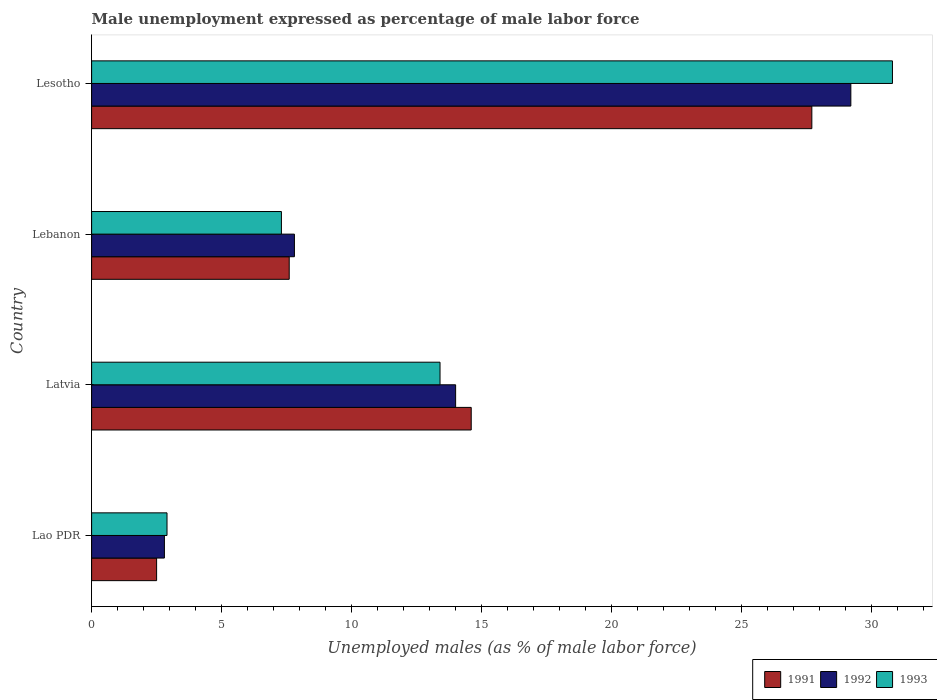Are the number of bars per tick equal to the number of legend labels?
Offer a very short reply. Yes. How many bars are there on the 2nd tick from the top?
Your answer should be compact. 3. How many bars are there on the 3rd tick from the bottom?
Provide a short and direct response. 3. What is the label of the 1st group of bars from the top?
Give a very brief answer. Lesotho. In how many cases, is the number of bars for a given country not equal to the number of legend labels?
Your response must be concise. 0. What is the unemployment in males in in 1993 in Lao PDR?
Keep it short and to the point. 2.9. Across all countries, what is the maximum unemployment in males in in 1993?
Give a very brief answer. 30.8. In which country was the unemployment in males in in 1991 maximum?
Give a very brief answer. Lesotho. In which country was the unemployment in males in in 1993 minimum?
Make the answer very short. Lao PDR. What is the total unemployment in males in in 1992 in the graph?
Your answer should be compact. 53.8. What is the difference between the unemployment in males in in 1993 in Lebanon and that in Lesotho?
Your answer should be very brief. -23.5. What is the difference between the unemployment in males in in 1992 in Lesotho and the unemployment in males in in 1991 in Lebanon?
Offer a terse response. 21.6. What is the average unemployment in males in in 1992 per country?
Your response must be concise. 13.45. What is the difference between the unemployment in males in in 1993 and unemployment in males in in 1991 in Lesotho?
Offer a terse response. 3.1. What is the ratio of the unemployment in males in in 1993 in Lebanon to that in Lesotho?
Ensure brevity in your answer.  0.24. Is the unemployment in males in in 1991 in Lao PDR less than that in Lebanon?
Provide a succinct answer. Yes. What is the difference between the highest and the second highest unemployment in males in in 1991?
Provide a succinct answer. 13.1. What is the difference between the highest and the lowest unemployment in males in in 1991?
Offer a very short reply. 25.2. Is the sum of the unemployment in males in in 1992 in Latvia and Lebanon greater than the maximum unemployment in males in in 1991 across all countries?
Your answer should be very brief. No. What does the 3rd bar from the top in Lesotho represents?
Offer a very short reply. 1991. How many bars are there?
Give a very brief answer. 12. How many countries are there in the graph?
Your answer should be compact. 4. What is the difference between two consecutive major ticks on the X-axis?
Give a very brief answer. 5. Does the graph contain any zero values?
Your answer should be very brief. No. Does the graph contain grids?
Provide a succinct answer. No. Where does the legend appear in the graph?
Offer a very short reply. Bottom right. How many legend labels are there?
Your answer should be compact. 3. How are the legend labels stacked?
Give a very brief answer. Horizontal. What is the title of the graph?
Provide a short and direct response. Male unemployment expressed as percentage of male labor force. What is the label or title of the X-axis?
Your answer should be very brief. Unemployed males (as % of male labor force). What is the label or title of the Y-axis?
Provide a succinct answer. Country. What is the Unemployed males (as % of male labor force) in 1992 in Lao PDR?
Offer a very short reply. 2.8. What is the Unemployed males (as % of male labor force) in 1993 in Lao PDR?
Your response must be concise. 2.9. What is the Unemployed males (as % of male labor force) of 1991 in Latvia?
Ensure brevity in your answer.  14.6. What is the Unemployed males (as % of male labor force) in 1992 in Latvia?
Offer a terse response. 14. What is the Unemployed males (as % of male labor force) in 1993 in Latvia?
Provide a short and direct response. 13.4. What is the Unemployed males (as % of male labor force) of 1991 in Lebanon?
Your answer should be compact. 7.6. What is the Unemployed males (as % of male labor force) of 1992 in Lebanon?
Your response must be concise. 7.8. What is the Unemployed males (as % of male labor force) in 1993 in Lebanon?
Ensure brevity in your answer.  7.3. What is the Unemployed males (as % of male labor force) of 1991 in Lesotho?
Your response must be concise. 27.7. What is the Unemployed males (as % of male labor force) in 1992 in Lesotho?
Keep it short and to the point. 29.2. What is the Unemployed males (as % of male labor force) of 1993 in Lesotho?
Offer a very short reply. 30.8. Across all countries, what is the maximum Unemployed males (as % of male labor force) of 1991?
Provide a succinct answer. 27.7. Across all countries, what is the maximum Unemployed males (as % of male labor force) of 1992?
Keep it short and to the point. 29.2. Across all countries, what is the maximum Unemployed males (as % of male labor force) of 1993?
Give a very brief answer. 30.8. Across all countries, what is the minimum Unemployed males (as % of male labor force) in 1992?
Your answer should be very brief. 2.8. Across all countries, what is the minimum Unemployed males (as % of male labor force) in 1993?
Provide a succinct answer. 2.9. What is the total Unemployed males (as % of male labor force) in 1991 in the graph?
Provide a succinct answer. 52.4. What is the total Unemployed males (as % of male labor force) of 1992 in the graph?
Your response must be concise. 53.8. What is the total Unemployed males (as % of male labor force) of 1993 in the graph?
Your response must be concise. 54.4. What is the difference between the Unemployed males (as % of male labor force) of 1992 in Lao PDR and that in Latvia?
Your answer should be very brief. -11.2. What is the difference between the Unemployed males (as % of male labor force) of 1991 in Lao PDR and that in Lebanon?
Your answer should be very brief. -5.1. What is the difference between the Unemployed males (as % of male labor force) in 1991 in Lao PDR and that in Lesotho?
Keep it short and to the point. -25.2. What is the difference between the Unemployed males (as % of male labor force) of 1992 in Lao PDR and that in Lesotho?
Keep it short and to the point. -26.4. What is the difference between the Unemployed males (as % of male labor force) in 1993 in Lao PDR and that in Lesotho?
Your response must be concise. -27.9. What is the difference between the Unemployed males (as % of male labor force) of 1991 in Latvia and that in Lebanon?
Make the answer very short. 7. What is the difference between the Unemployed males (as % of male labor force) in 1993 in Latvia and that in Lebanon?
Make the answer very short. 6.1. What is the difference between the Unemployed males (as % of male labor force) of 1991 in Latvia and that in Lesotho?
Your response must be concise. -13.1. What is the difference between the Unemployed males (as % of male labor force) in 1992 in Latvia and that in Lesotho?
Ensure brevity in your answer.  -15.2. What is the difference between the Unemployed males (as % of male labor force) of 1993 in Latvia and that in Lesotho?
Provide a short and direct response. -17.4. What is the difference between the Unemployed males (as % of male labor force) in 1991 in Lebanon and that in Lesotho?
Ensure brevity in your answer.  -20.1. What is the difference between the Unemployed males (as % of male labor force) of 1992 in Lebanon and that in Lesotho?
Provide a short and direct response. -21.4. What is the difference between the Unemployed males (as % of male labor force) of 1993 in Lebanon and that in Lesotho?
Offer a terse response. -23.5. What is the difference between the Unemployed males (as % of male labor force) of 1992 in Lao PDR and the Unemployed males (as % of male labor force) of 1993 in Latvia?
Your answer should be compact. -10.6. What is the difference between the Unemployed males (as % of male labor force) in 1991 in Lao PDR and the Unemployed males (as % of male labor force) in 1992 in Lebanon?
Your answer should be very brief. -5.3. What is the difference between the Unemployed males (as % of male labor force) in 1991 in Lao PDR and the Unemployed males (as % of male labor force) in 1992 in Lesotho?
Ensure brevity in your answer.  -26.7. What is the difference between the Unemployed males (as % of male labor force) in 1991 in Lao PDR and the Unemployed males (as % of male labor force) in 1993 in Lesotho?
Ensure brevity in your answer.  -28.3. What is the difference between the Unemployed males (as % of male labor force) of 1991 in Latvia and the Unemployed males (as % of male labor force) of 1993 in Lebanon?
Ensure brevity in your answer.  7.3. What is the difference between the Unemployed males (as % of male labor force) in 1991 in Latvia and the Unemployed males (as % of male labor force) in 1992 in Lesotho?
Offer a terse response. -14.6. What is the difference between the Unemployed males (as % of male labor force) of 1991 in Latvia and the Unemployed males (as % of male labor force) of 1993 in Lesotho?
Your answer should be very brief. -16.2. What is the difference between the Unemployed males (as % of male labor force) in 1992 in Latvia and the Unemployed males (as % of male labor force) in 1993 in Lesotho?
Your answer should be compact. -16.8. What is the difference between the Unemployed males (as % of male labor force) of 1991 in Lebanon and the Unemployed males (as % of male labor force) of 1992 in Lesotho?
Your answer should be very brief. -21.6. What is the difference between the Unemployed males (as % of male labor force) of 1991 in Lebanon and the Unemployed males (as % of male labor force) of 1993 in Lesotho?
Provide a succinct answer. -23.2. What is the difference between the Unemployed males (as % of male labor force) of 1992 in Lebanon and the Unemployed males (as % of male labor force) of 1993 in Lesotho?
Offer a terse response. -23. What is the average Unemployed males (as % of male labor force) of 1992 per country?
Make the answer very short. 13.45. What is the average Unemployed males (as % of male labor force) of 1993 per country?
Your response must be concise. 13.6. What is the difference between the Unemployed males (as % of male labor force) of 1991 and Unemployed males (as % of male labor force) of 1992 in Lao PDR?
Your answer should be compact. -0.3. What is the difference between the Unemployed males (as % of male labor force) in 1991 and Unemployed males (as % of male labor force) in 1993 in Lao PDR?
Your answer should be very brief. -0.4. What is the difference between the Unemployed males (as % of male labor force) in 1991 and Unemployed males (as % of male labor force) in 1992 in Latvia?
Keep it short and to the point. 0.6. What is the difference between the Unemployed males (as % of male labor force) in 1991 and Unemployed males (as % of male labor force) in 1993 in Latvia?
Your response must be concise. 1.2. What is the difference between the Unemployed males (as % of male labor force) of 1992 and Unemployed males (as % of male labor force) of 1993 in Latvia?
Offer a very short reply. 0.6. What is the difference between the Unemployed males (as % of male labor force) of 1992 and Unemployed males (as % of male labor force) of 1993 in Lebanon?
Give a very brief answer. 0.5. What is the difference between the Unemployed males (as % of male labor force) of 1991 and Unemployed males (as % of male labor force) of 1992 in Lesotho?
Offer a very short reply. -1.5. What is the difference between the Unemployed males (as % of male labor force) of 1991 and Unemployed males (as % of male labor force) of 1993 in Lesotho?
Your answer should be compact. -3.1. What is the ratio of the Unemployed males (as % of male labor force) in 1991 in Lao PDR to that in Latvia?
Provide a succinct answer. 0.17. What is the ratio of the Unemployed males (as % of male labor force) in 1993 in Lao PDR to that in Latvia?
Offer a terse response. 0.22. What is the ratio of the Unemployed males (as % of male labor force) of 1991 in Lao PDR to that in Lebanon?
Your response must be concise. 0.33. What is the ratio of the Unemployed males (as % of male labor force) of 1992 in Lao PDR to that in Lebanon?
Provide a short and direct response. 0.36. What is the ratio of the Unemployed males (as % of male labor force) in 1993 in Lao PDR to that in Lebanon?
Your response must be concise. 0.4. What is the ratio of the Unemployed males (as % of male labor force) in 1991 in Lao PDR to that in Lesotho?
Make the answer very short. 0.09. What is the ratio of the Unemployed males (as % of male labor force) in 1992 in Lao PDR to that in Lesotho?
Keep it short and to the point. 0.1. What is the ratio of the Unemployed males (as % of male labor force) of 1993 in Lao PDR to that in Lesotho?
Your answer should be compact. 0.09. What is the ratio of the Unemployed males (as % of male labor force) in 1991 in Latvia to that in Lebanon?
Offer a very short reply. 1.92. What is the ratio of the Unemployed males (as % of male labor force) of 1992 in Latvia to that in Lebanon?
Give a very brief answer. 1.79. What is the ratio of the Unemployed males (as % of male labor force) of 1993 in Latvia to that in Lebanon?
Your answer should be very brief. 1.84. What is the ratio of the Unemployed males (as % of male labor force) of 1991 in Latvia to that in Lesotho?
Make the answer very short. 0.53. What is the ratio of the Unemployed males (as % of male labor force) of 1992 in Latvia to that in Lesotho?
Keep it short and to the point. 0.48. What is the ratio of the Unemployed males (as % of male labor force) of 1993 in Latvia to that in Lesotho?
Make the answer very short. 0.44. What is the ratio of the Unemployed males (as % of male labor force) in 1991 in Lebanon to that in Lesotho?
Offer a very short reply. 0.27. What is the ratio of the Unemployed males (as % of male labor force) of 1992 in Lebanon to that in Lesotho?
Your response must be concise. 0.27. What is the ratio of the Unemployed males (as % of male labor force) of 1993 in Lebanon to that in Lesotho?
Keep it short and to the point. 0.24. What is the difference between the highest and the second highest Unemployed males (as % of male labor force) in 1991?
Your answer should be very brief. 13.1. What is the difference between the highest and the second highest Unemployed males (as % of male labor force) in 1992?
Your answer should be compact. 15.2. What is the difference between the highest and the second highest Unemployed males (as % of male labor force) in 1993?
Ensure brevity in your answer.  17.4. What is the difference between the highest and the lowest Unemployed males (as % of male labor force) of 1991?
Offer a very short reply. 25.2. What is the difference between the highest and the lowest Unemployed males (as % of male labor force) of 1992?
Ensure brevity in your answer.  26.4. What is the difference between the highest and the lowest Unemployed males (as % of male labor force) of 1993?
Offer a very short reply. 27.9. 